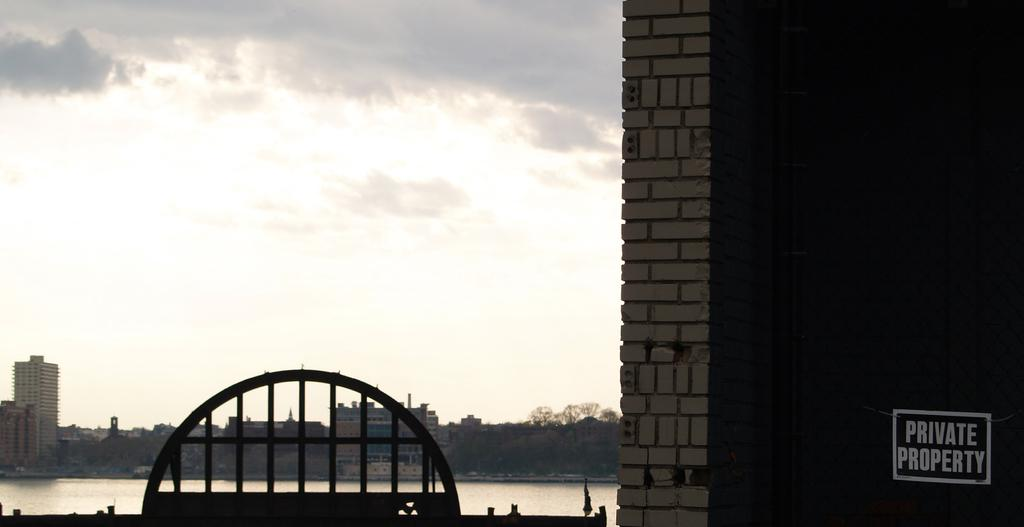<image>
Relay a brief, clear account of the picture shown. A riverside view of a city next to a sign that says private propert 